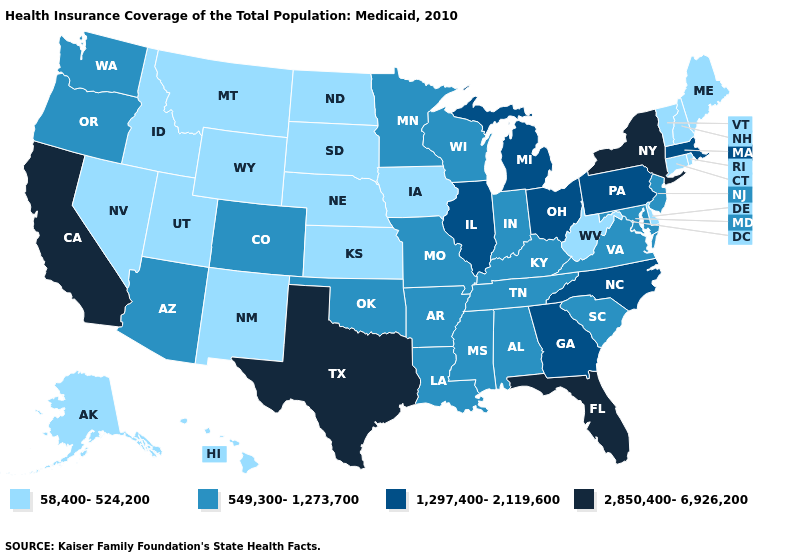What is the highest value in the USA?
Short answer required. 2,850,400-6,926,200. Which states hav the highest value in the West?
Give a very brief answer. California. Name the states that have a value in the range 2,850,400-6,926,200?
Give a very brief answer. California, Florida, New York, Texas. How many symbols are there in the legend?
Be succinct. 4. Name the states that have a value in the range 2,850,400-6,926,200?
Quick response, please. California, Florida, New York, Texas. What is the lowest value in states that border Washington?
Write a very short answer. 58,400-524,200. What is the value of South Carolina?
Answer briefly. 549,300-1,273,700. What is the highest value in the MidWest ?
Give a very brief answer. 1,297,400-2,119,600. Does Florida have the highest value in the South?
Short answer required. Yes. What is the value of Tennessee?
Concise answer only. 549,300-1,273,700. Which states hav the highest value in the South?
Write a very short answer. Florida, Texas. Does Utah have the lowest value in the USA?
Short answer required. Yes. Does the map have missing data?
Quick response, please. No. Does Connecticut have the highest value in the USA?
Short answer required. No. What is the lowest value in the USA?
Be succinct. 58,400-524,200. 